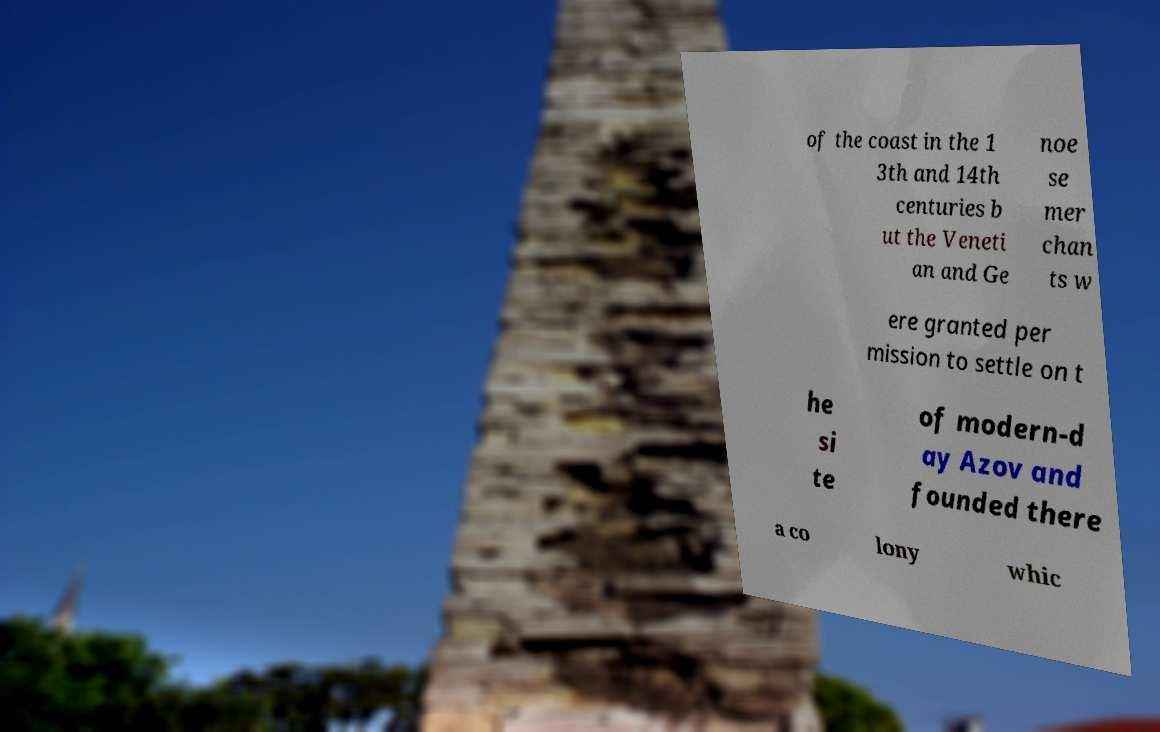Could you extract and type out the text from this image? of the coast in the 1 3th and 14th centuries b ut the Veneti an and Ge noe se mer chan ts w ere granted per mission to settle on t he si te of modern-d ay Azov and founded there a co lony whic 